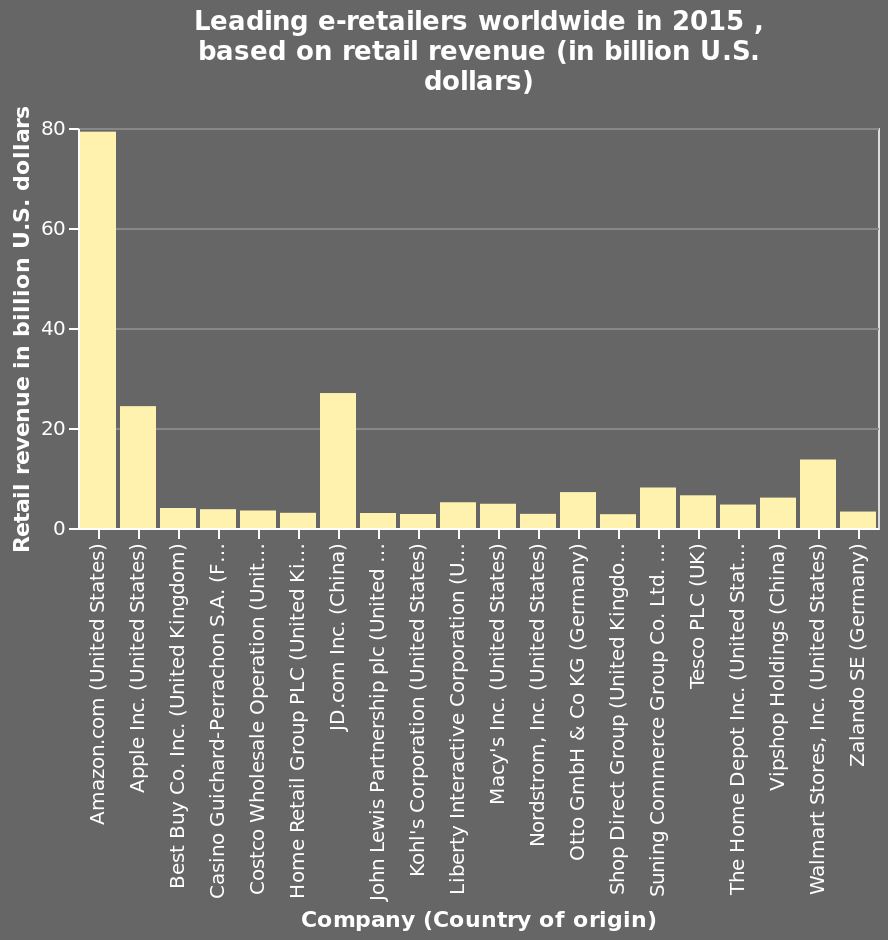<image>
What is the maximum value on the y-axis? The maximum value on the y-axis is 80 billion U.S. dollars. What does the y-axis measure?  The y-axis measures retail revenue in billion U.S. dollars. 